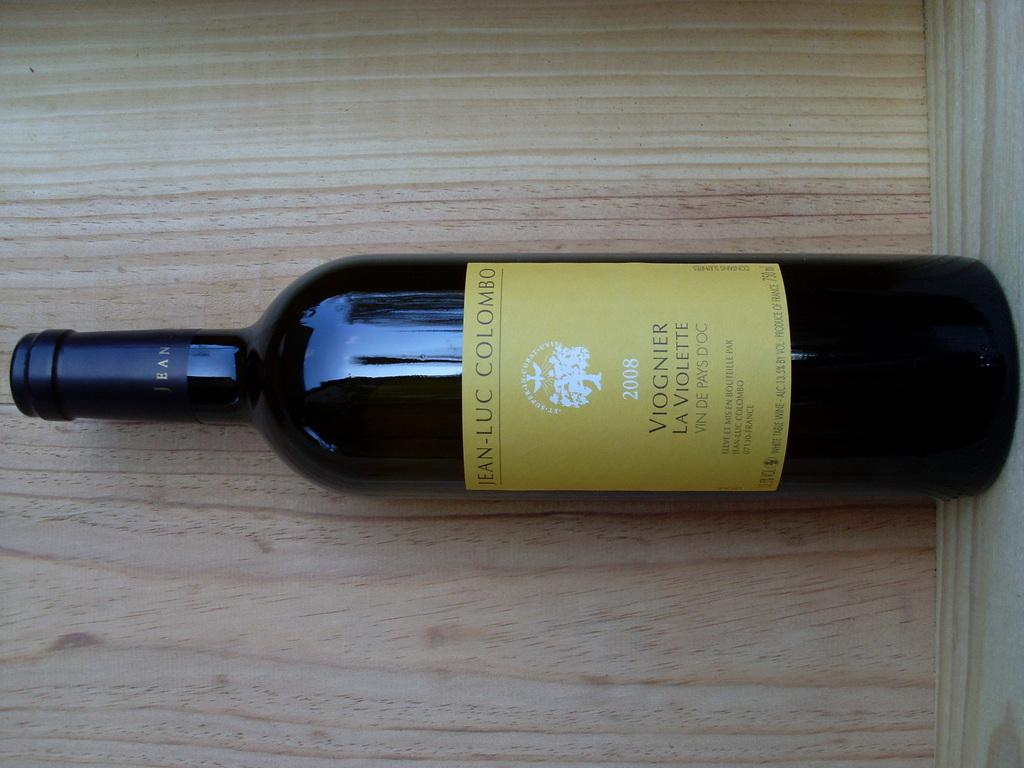What object is present in the image that might contain a liquid? There is a bottle in the image. What distinguishing feature can be seen on the bottle? The bottle has a label. What is written or depicted on the label? The label has text on it. Where is the bottle located in the image? The bottle is on a wooden plank. How does the bottle express shame in the image? The bottle does not express shame in the image, as it is an inanimate object and cannot experience emotions. 